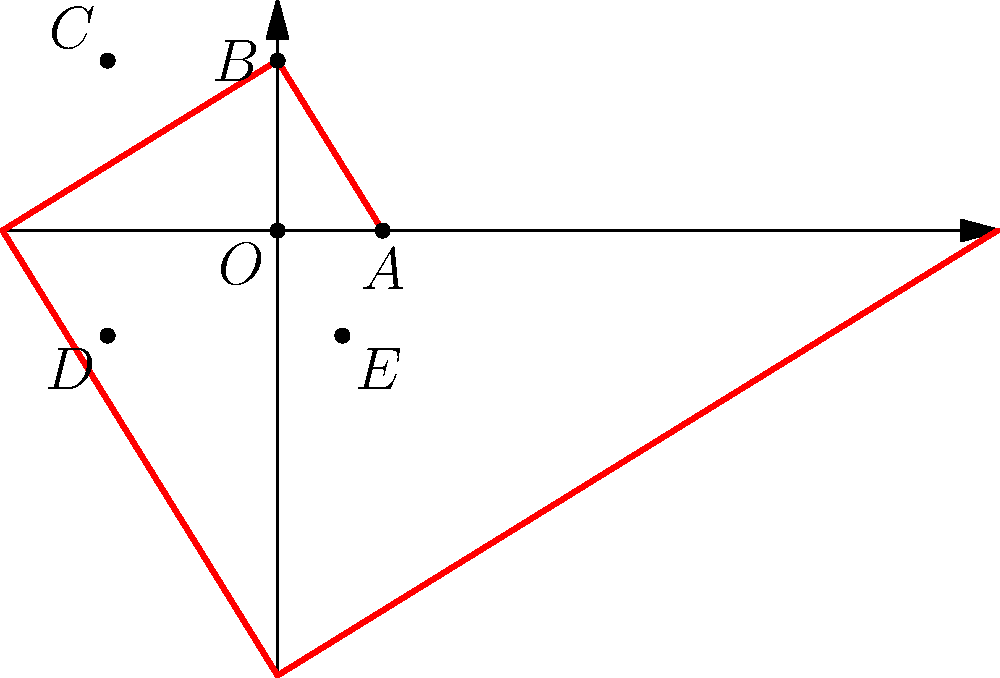In the spiral pattern shown above, points A, B, C, D, and E are connected by arcs of a quarter circle. If OA = 1 unit, calculate the length of OE to determine the golden ratio. How does this relate to the Fibonacci sequence often used in contemporary art? To solve this problem, we'll follow these steps:

1) The golden ratio, denoted by $\phi$ (phi), is defined as $\phi = \frac{1 + \sqrt{5}}{2} \approx 1.618033988749895$.

2) In the spiral, each segment is $\phi$ times longer than the previous one. Let's trace the path:

   OA = 1
   AB = $\phi$
   BC = $\phi^2$
   CD = $\phi^3$
   DE = $\phi^4$

3) The length of OE is the sum of these segments:

   OE = 1 + $\phi$ + $\phi^2$ + $\phi^3$ + $\phi^4$

4) This is a geometric series with 5 terms, first term $a=1$, and common ratio $r=\phi$.

5) The sum of a geometric series is given by the formula:
   $S_n = \frac{a(1-r^n)}{1-r}$ where $n$ is the number of terms.

6) Substituting our values:

   OE = $\frac{1(1-\phi^5)}{1-\phi}$

7) Simplify:
   OE = $\phi^5 - 1 = (\frac{1 + \sqrt{5}}{2})^5 - 1 \approx 11.090169943749475$

8) Relation to Fibonacci sequence:
   The ratio of consecutive Fibonacci numbers converges to the golden ratio as the sequence progresses. This sequence is often found in nature and used in art for its aesthetic appeal.

9) In contemporary art, especially for late bloomers, understanding this ratio can help in creating balanced and visually pleasing compositions, whether in painting, sculpture, or digital art.
Answer: OE $\approx 11.09$, Golden Ratio $\phi \approx 1.618$ 